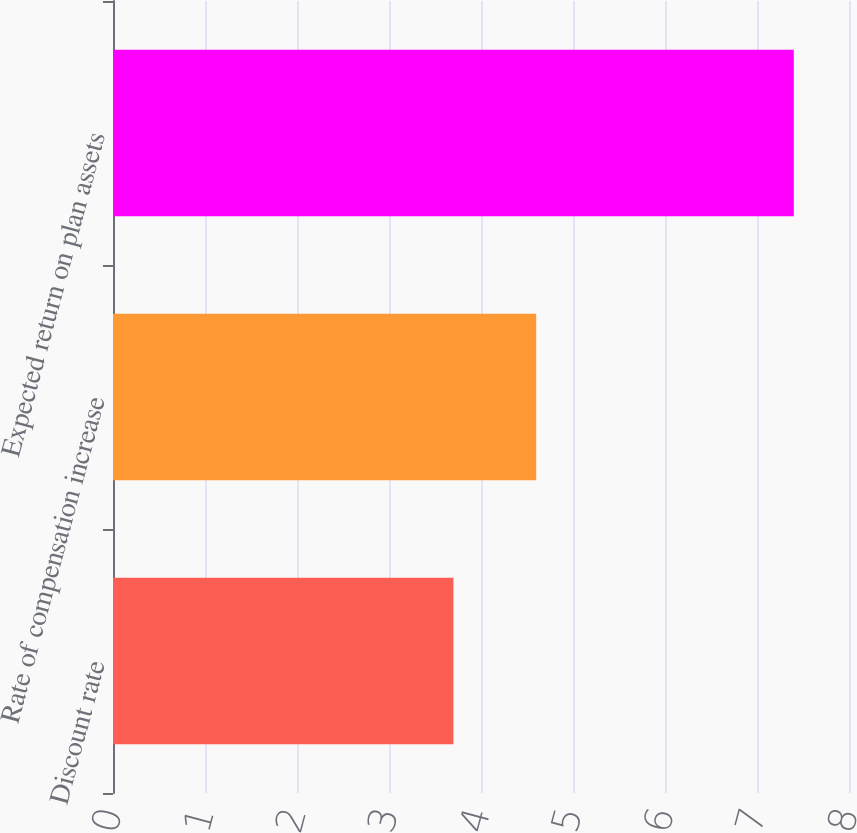<chart> <loc_0><loc_0><loc_500><loc_500><bar_chart><fcel>Discount rate<fcel>Rate of compensation increase<fcel>Expected return on plan assets<nl><fcel>3.7<fcel>4.6<fcel>7.4<nl></chart> 